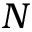<formula> <loc_0><loc_0><loc_500><loc_500>N</formula> 